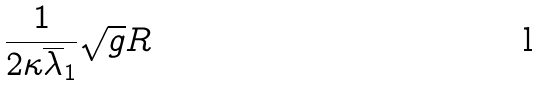<formula> <loc_0><loc_0><loc_500><loc_500>\frac { 1 } { 2 \kappa \overline { \lambda } _ { 1 } } \sqrt { g } R</formula> 